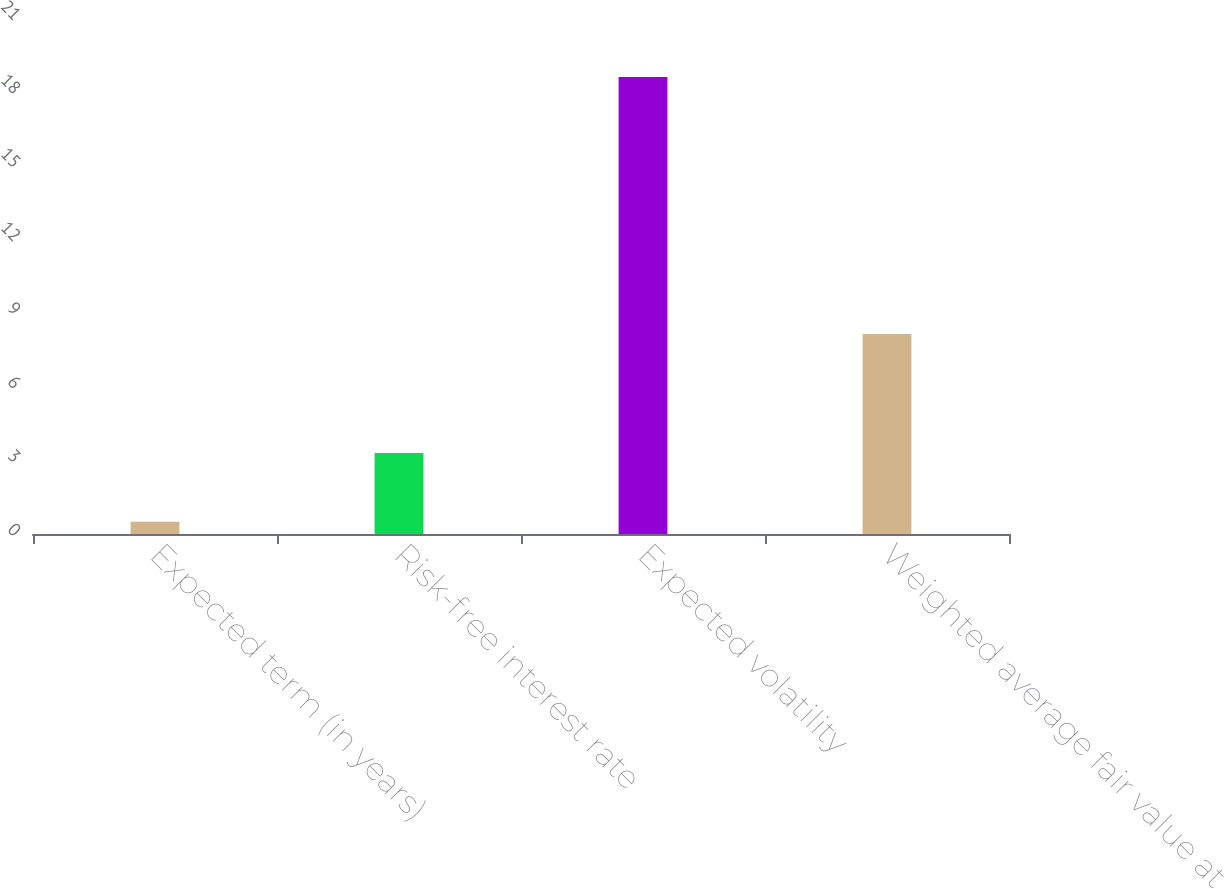Convert chart. <chart><loc_0><loc_0><loc_500><loc_500><bar_chart><fcel>Expected term (in years)<fcel>Risk-free interest rate<fcel>Expected volatility<fcel>Weighted average fair value at<nl><fcel>0.5<fcel>3.3<fcel>18.6<fcel>8.14<nl></chart> 